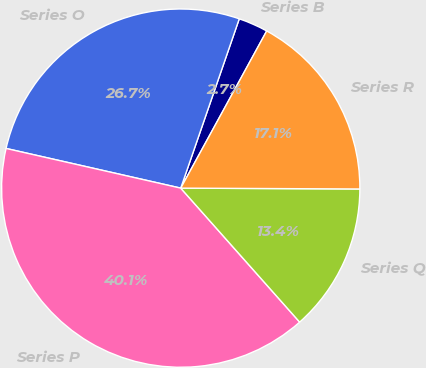<chart> <loc_0><loc_0><loc_500><loc_500><pie_chart><fcel>Series B<fcel>Series O<fcel>Series P<fcel>Series Q<fcel>Series R<nl><fcel>2.67%<fcel>26.74%<fcel>40.11%<fcel>13.37%<fcel>17.11%<nl></chart> 